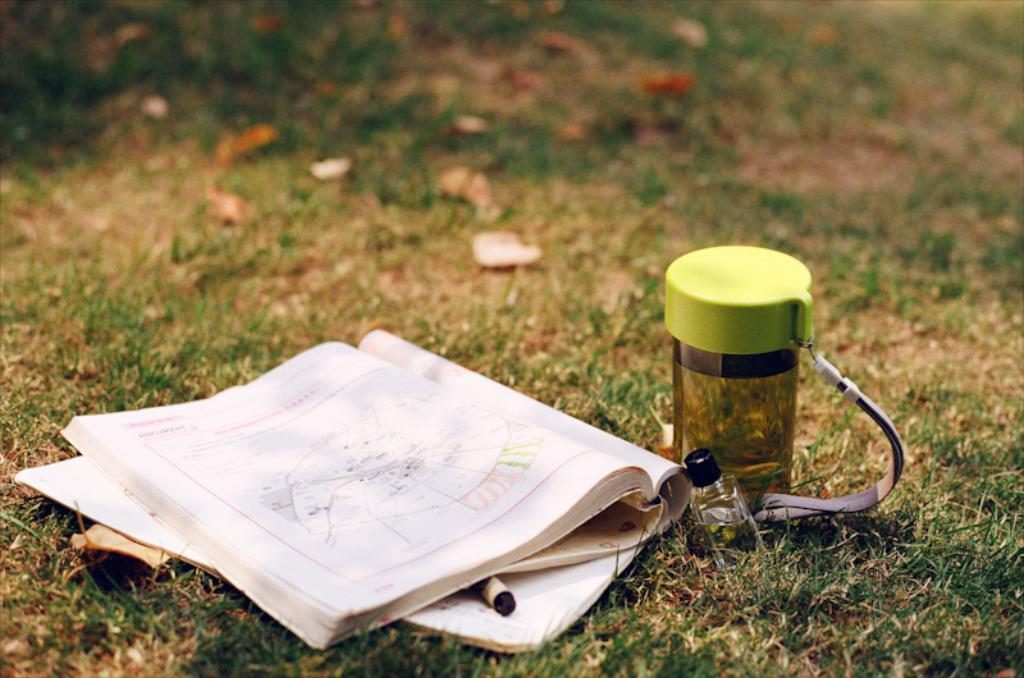What object can be seen in the image related to reading or learning? There is a book in the image. What object can be seen in the image related to hydration? There is a water bottle in the image. Where are the book and water bottle placed in the image? The book and water bottle are placed on the ground. What type of natural environment is visible in the image? Grass is visible in the image. What theory can be seen being tested in the image? There is no theory being tested in the image; it simply shows a book and water bottle placed on the ground in a grassy area. How does the breath of the person in the image affect the objects in the image? There is no person present in the image, so their breath cannot affect the objects. 